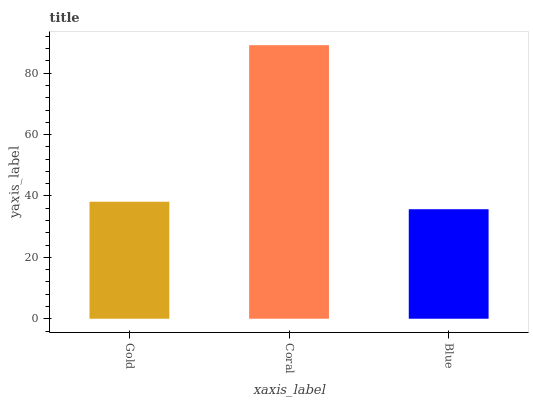Is Blue the minimum?
Answer yes or no. Yes. Is Coral the maximum?
Answer yes or no. Yes. Is Coral the minimum?
Answer yes or no. No. Is Blue the maximum?
Answer yes or no. No. Is Coral greater than Blue?
Answer yes or no. Yes. Is Blue less than Coral?
Answer yes or no. Yes. Is Blue greater than Coral?
Answer yes or no. No. Is Coral less than Blue?
Answer yes or no. No. Is Gold the high median?
Answer yes or no. Yes. Is Gold the low median?
Answer yes or no. Yes. Is Coral the high median?
Answer yes or no. No. Is Coral the low median?
Answer yes or no. No. 